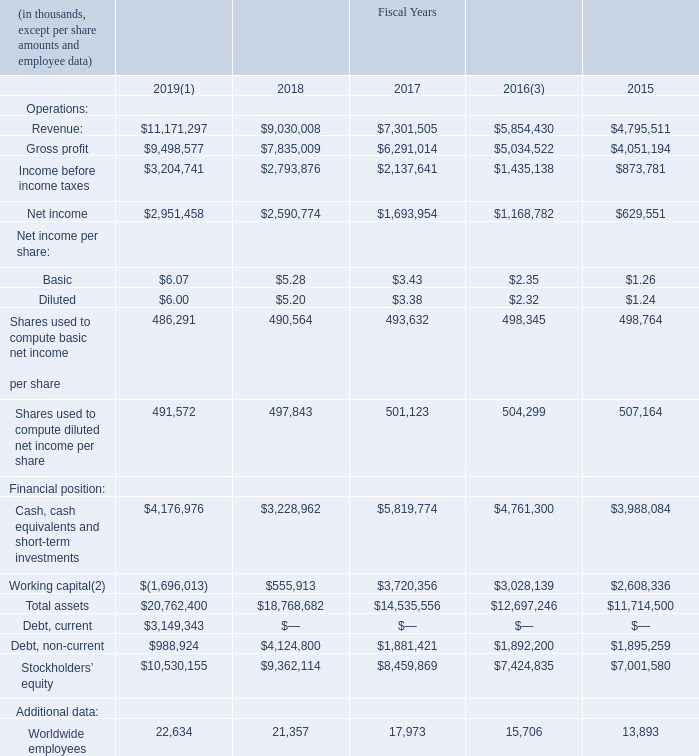ITEM 6. SELECTED FINANCIAL DATA
The following selected consolidated financial data is derived from our Consolidated Financial Statements. As our historical operating results are not necessarily indicative of future operating results, this data should be read in conjunction with the Consolidated Financial Statements and notes thereto, and with Item 7, Management’s Discussion and Analysis of Financial Condition and Results of Operations.
(1) On December 1, 2018, the beginning of our fiscal year 2019, we adopted the requirements of the Financial Accounting Standards Board’s Accounting Standards Update No. 2014-09, Revenue from Contracts with Customers, Topic 606, utilizing the modified retrospective method of transition. Prior period information has not been restated and continues to be reported under the accounting standard in effect for those periods.
(2) As of November 29, 2019, working capital was in a deficit primarily due to the reclassification of our $2.25 billion term loan due April 30, 2020 and $900 million 4.75% senior notes due February 1, 2020 to current liabilities. We intend to refinance our Term Loan and 2020 Notes on or before the due dates.
(3) Our fiscal year is a 52- or 53-week year that ends on the Friday closest to November 30. Fiscal 2016 was a 53-week fiscal year compared with the other periods presented which were 52-week fiscal years.
What was the gross profit margin in 2018?
Answer scale should be: percent. 7,835,009/9,030,008
Answer: 86.77. Why was the working capital negative in 2019? Working capital was in a deficit primarily due to the reclassification of our $2.25 billion term loan due april 30, 2020 and $900 million 4.75% senior notes due february 1, 2020 to current liabilities. What is the total liabilities of the company in 2019?
Answer scale should be: thousand. 3,149,343 + 988,924
Answer: 4138267. What was the total net income of basic shares in 2019? 486,291 * $6.07
Answer: 2951786.37. What type is the year 2016, 52-week or 53-week? 53-week. When did the company adopt the requirements of the Financial Accounting Standards Board's Accounting Standards Update No. 2014-09, Revenue from Contracts with Customers, Topic 606, utilizing the modified retrospective method of transition? December 1, 2018. 